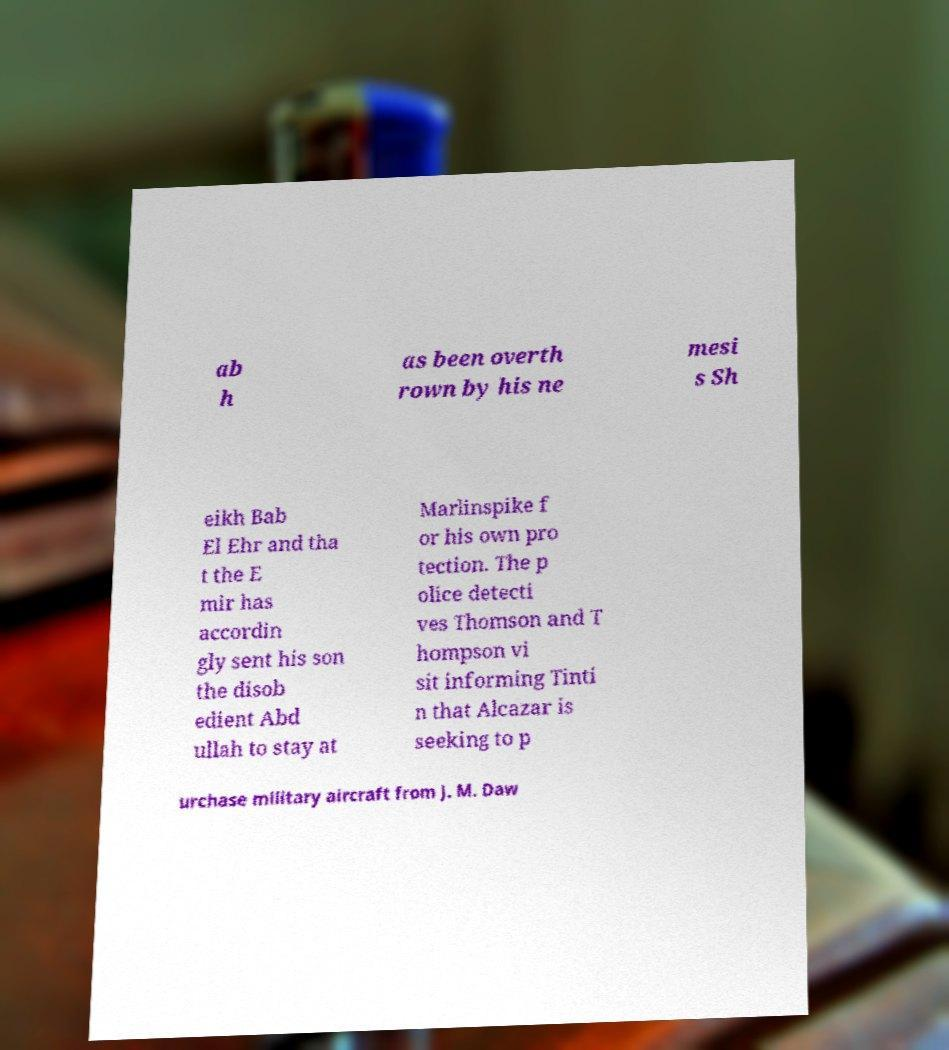For documentation purposes, I need the text within this image transcribed. Could you provide that? ab h as been overth rown by his ne mesi s Sh eikh Bab El Ehr and tha t the E mir has accordin gly sent his son the disob edient Abd ullah to stay at Marlinspike f or his own pro tection. The p olice detecti ves Thomson and T hompson vi sit informing Tinti n that Alcazar is seeking to p urchase military aircraft from J. M. Daw 